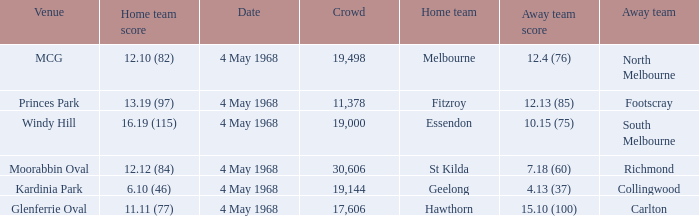How big was the crowd of the team that scored 4.13 (37)? 19144.0. 